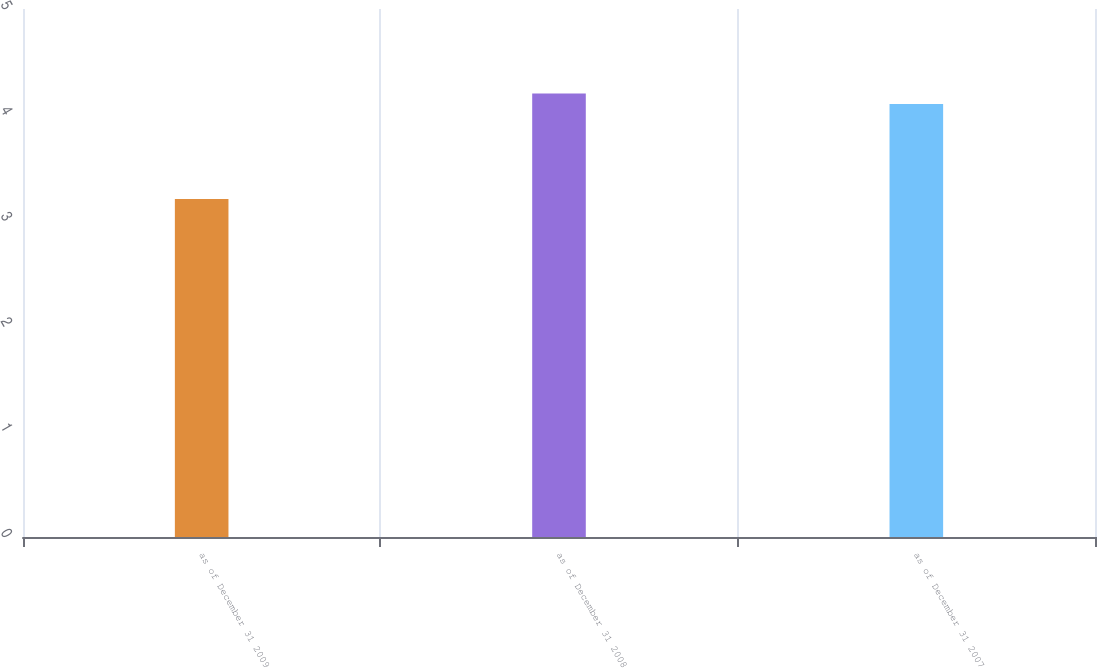Convert chart to OTSL. <chart><loc_0><loc_0><loc_500><loc_500><bar_chart><fcel>as of December 31 2009<fcel>as of December 31 2008<fcel>as of December 31 2007<nl><fcel>3.2<fcel>4.2<fcel>4.1<nl></chart> 